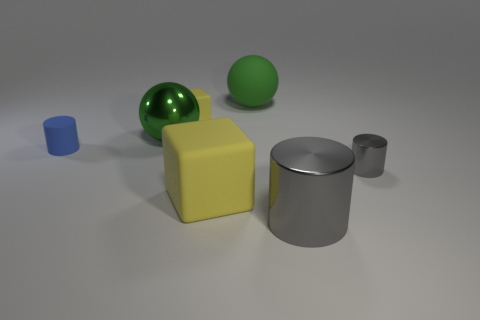What is the color of the large rubber sphere?
Offer a terse response. Green. Is the size of the blue matte object the same as the green rubber object?
Your answer should be compact. No. How many things are large green shiny things or small yellow cubes?
Your response must be concise. 2. Is the number of large gray cylinders that are in front of the large gray object the same as the number of gray metallic things?
Keep it short and to the point. No. There is a cylinder that is on the left side of the green sphere that is to the right of the big yellow matte cube; is there a matte cylinder that is to the right of it?
Keep it short and to the point. No. There is a big sphere that is the same material as the big block; what is its color?
Give a very brief answer. Green. Does the metal thing behind the blue rubber object have the same color as the large rubber cube?
Offer a terse response. No. How many balls are either green metal things or tiny things?
Provide a short and direct response. 1. What is the size of the block that is behind the rubber object on the left side of the matte cube behind the tiny gray cylinder?
Ensure brevity in your answer.  Small. What is the shape of the green rubber thing that is the same size as the metallic ball?
Keep it short and to the point. Sphere. 